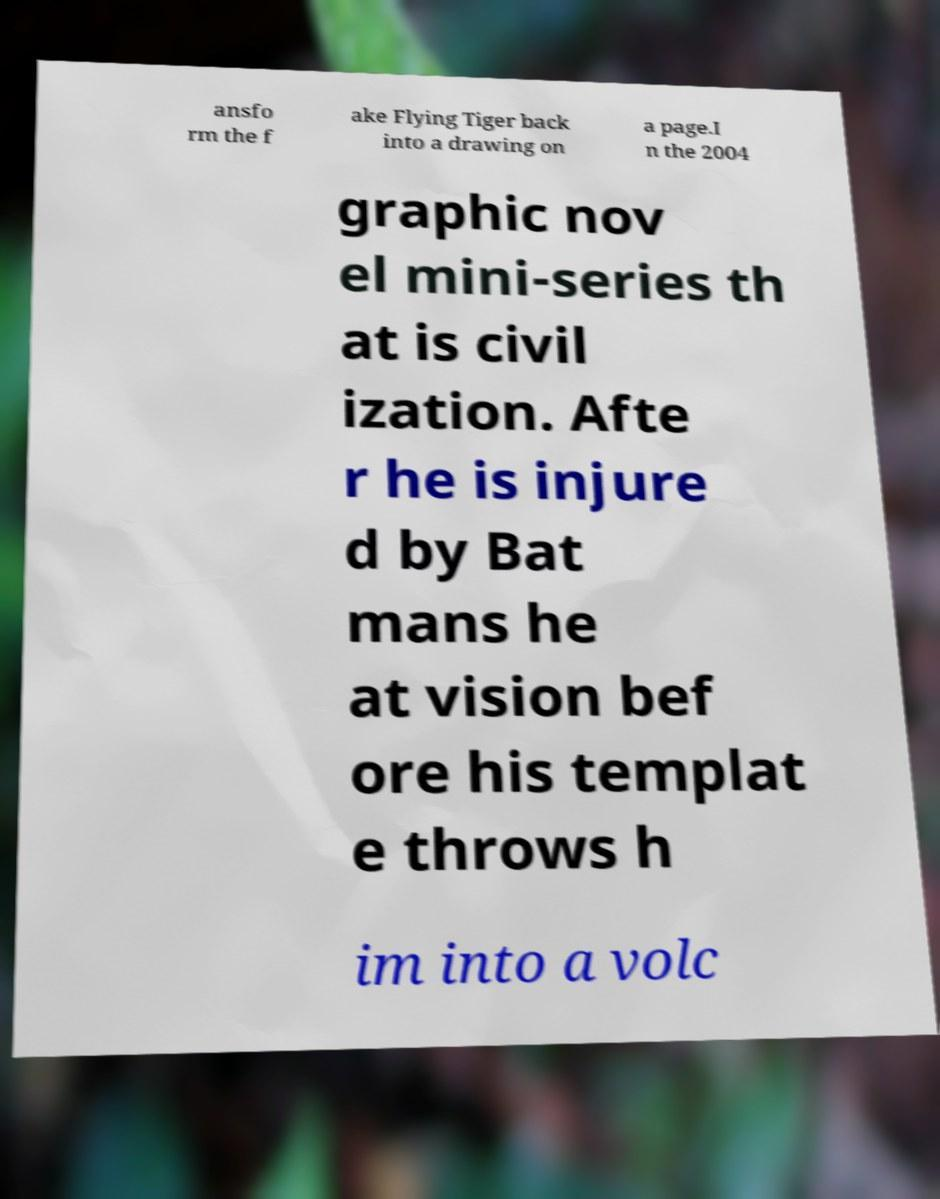I need the written content from this picture converted into text. Can you do that? ansfo rm the f ake Flying Tiger back into a drawing on a page.I n the 2004 graphic nov el mini-series th at is civil ization. Afte r he is injure d by Bat mans he at vision bef ore his templat e throws h im into a volc 